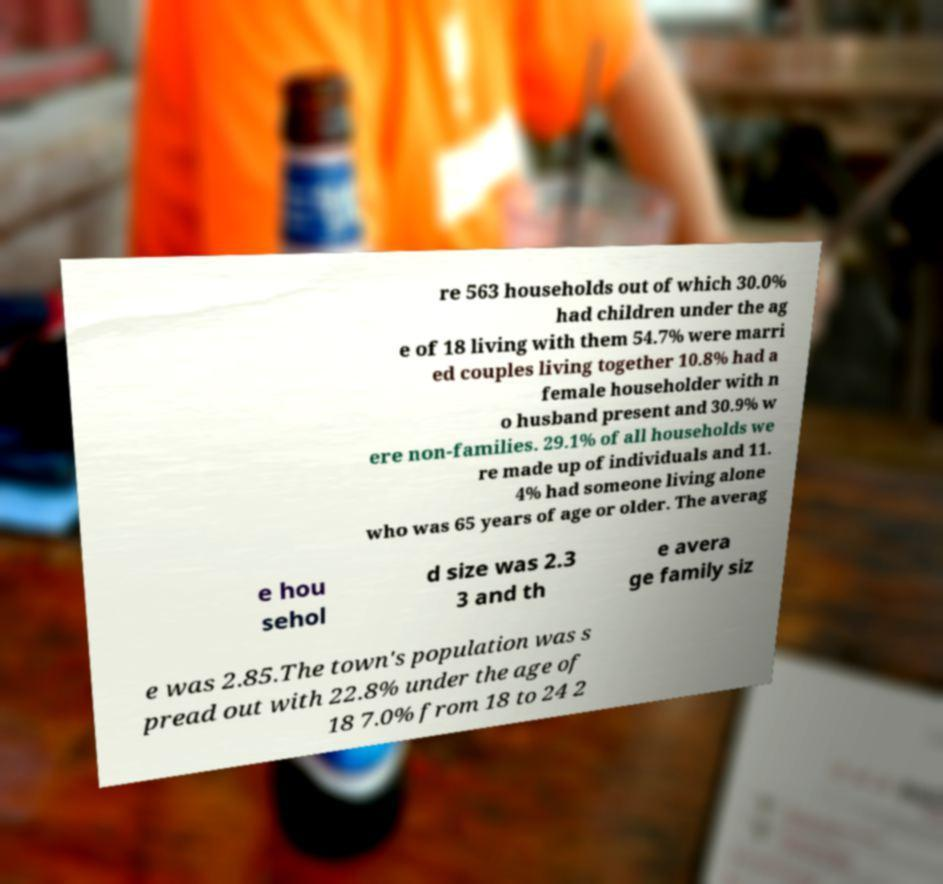What messages or text are displayed in this image? I need them in a readable, typed format. re 563 households out of which 30.0% had children under the ag e of 18 living with them 54.7% were marri ed couples living together 10.8% had a female householder with n o husband present and 30.9% w ere non-families. 29.1% of all households we re made up of individuals and 11. 4% had someone living alone who was 65 years of age or older. The averag e hou sehol d size was 2.3 3 and th e avera ge family siz e was 2.85.The town's population was s pread out with 22.8% under the age of 18 7.0% from 18 to 24 2 